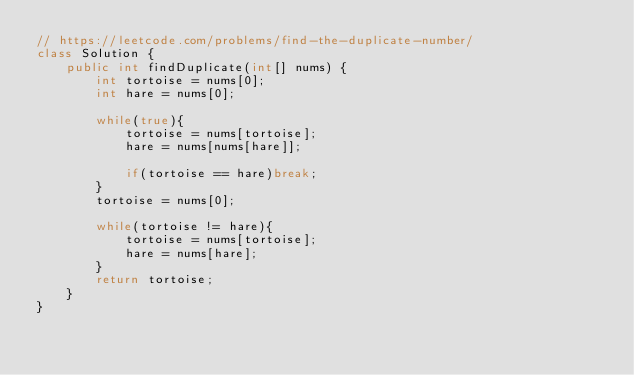Convert code to text. <code><loc_0><loc_0><loc_500><loc_500><_Java_>// https://leetcode.com/problems/find-the-duplicate-number/
class Solution {
    public int findDuplicate(int[] nums) {
        int tortoise = nums[0];
        int hare = nums[0];
        
        while(true){
            tortoise = nums[tortoise];
            hare = nums[nums[hare]];

            if(tortoise == hare)break;
        }
        tortoise = nums[0];
        
        while(tortoise != hare){
            tortoise = nums[tortoise];
            hare = nums[hare];
        }
        return tortoise;
    }
}
</code> 